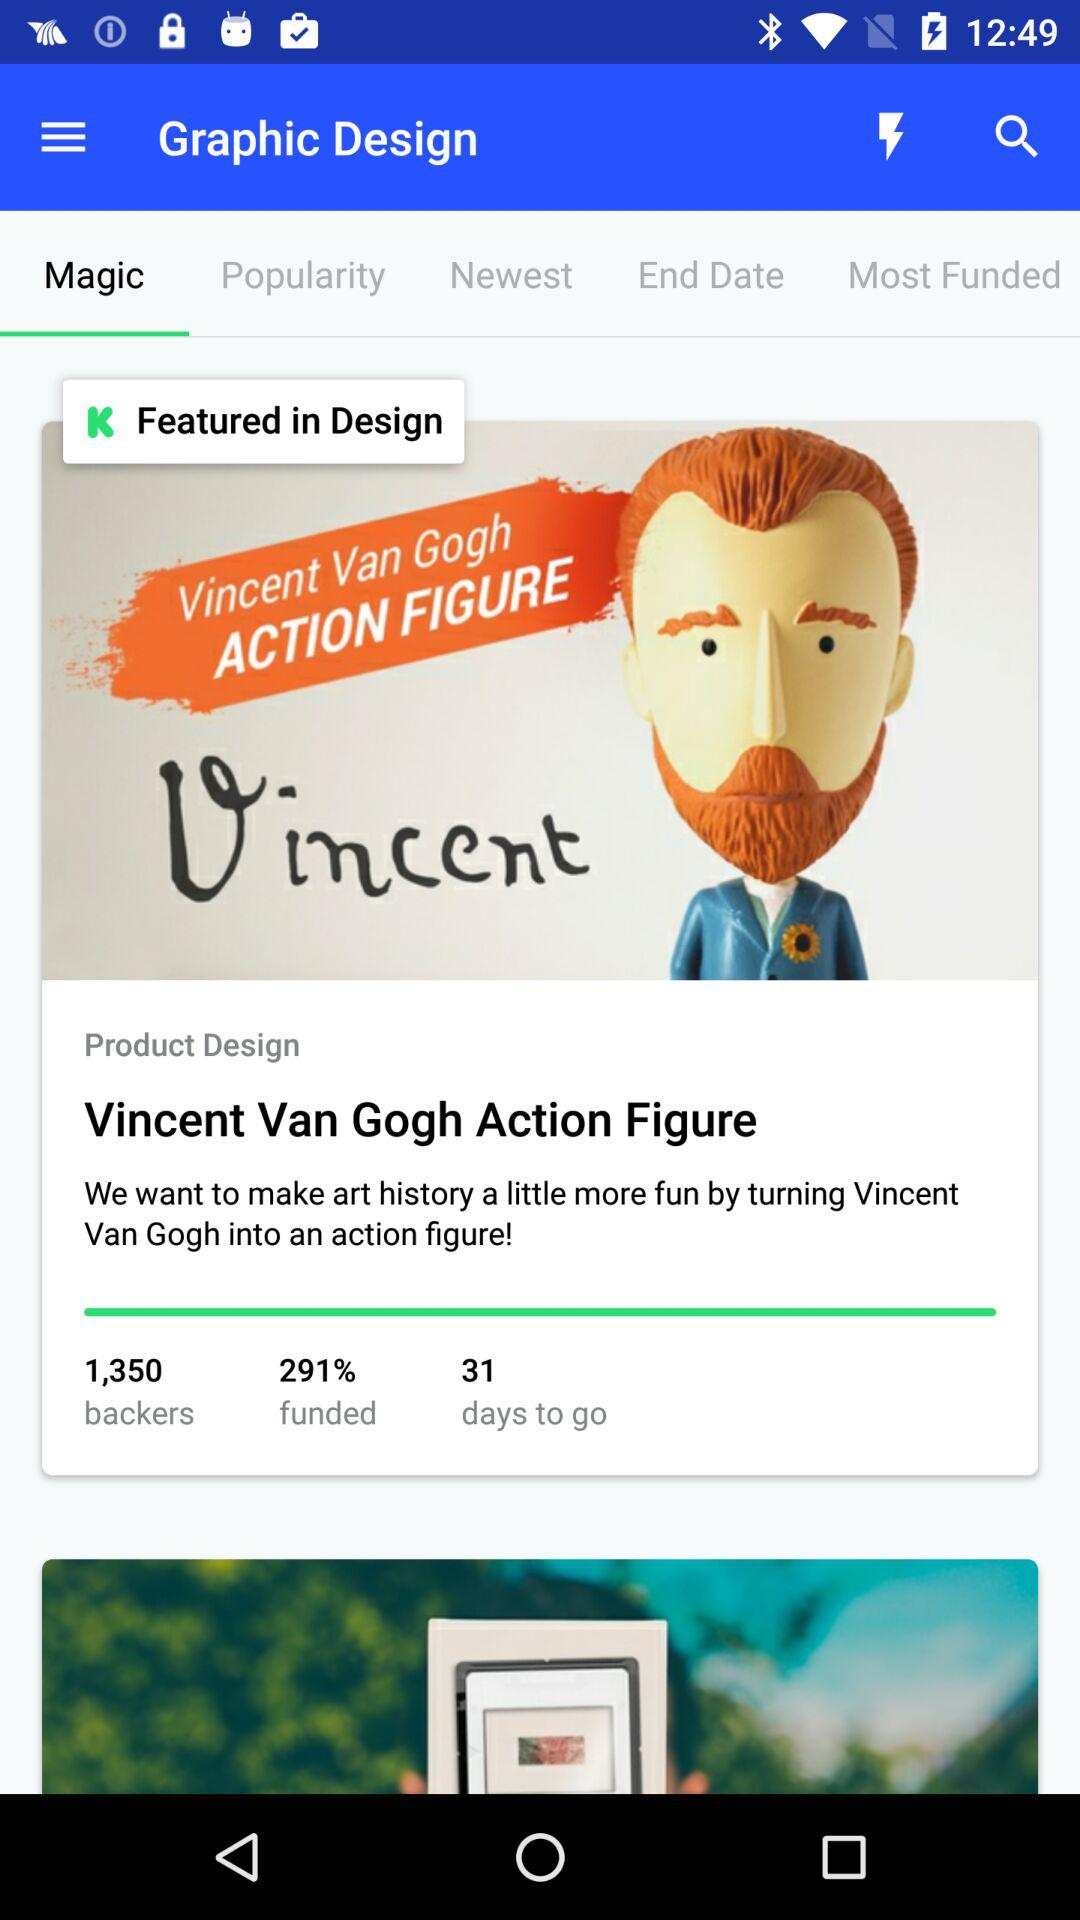What is the "funded percentage"? The percentage is 291. 